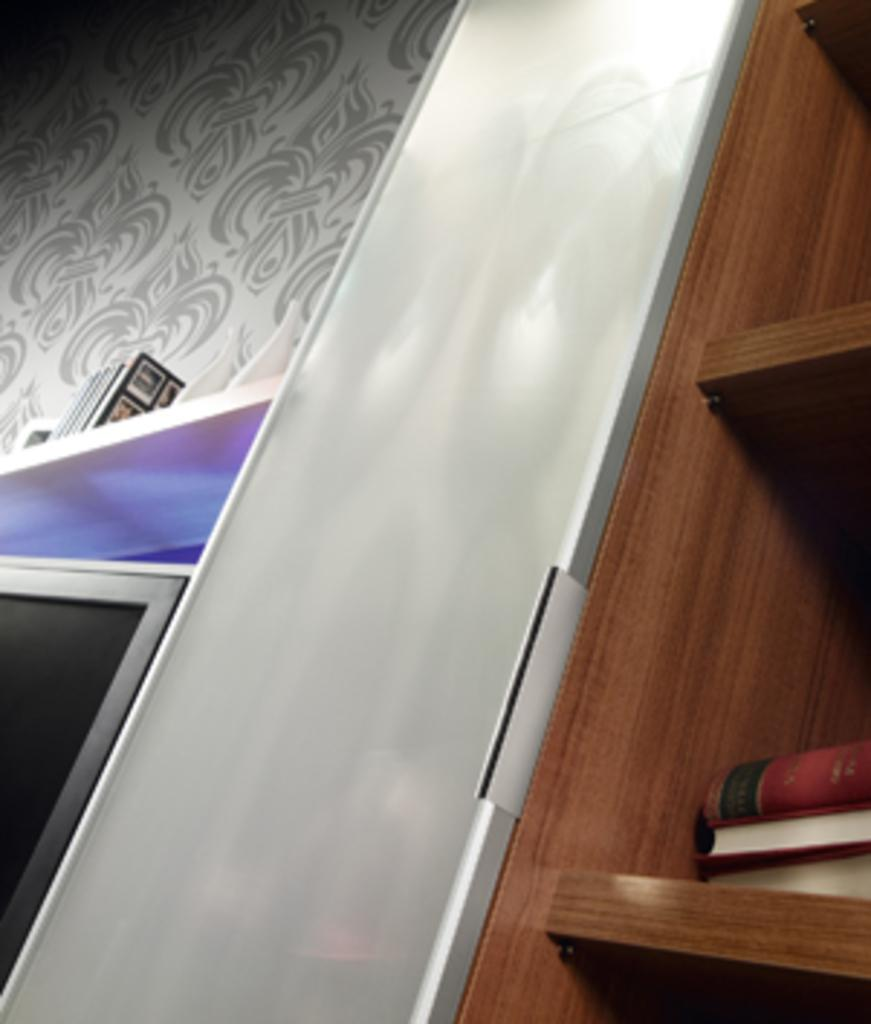What type of furniture is present in the image? There is a bookshelf in the image. What can be seen on the wall in the image? The wall has a decoration. How does the watch on the bookshelf help with balancing the books? There is no watch present on the bookshelf in the image, and therefore it cannot help with balancing the books. 